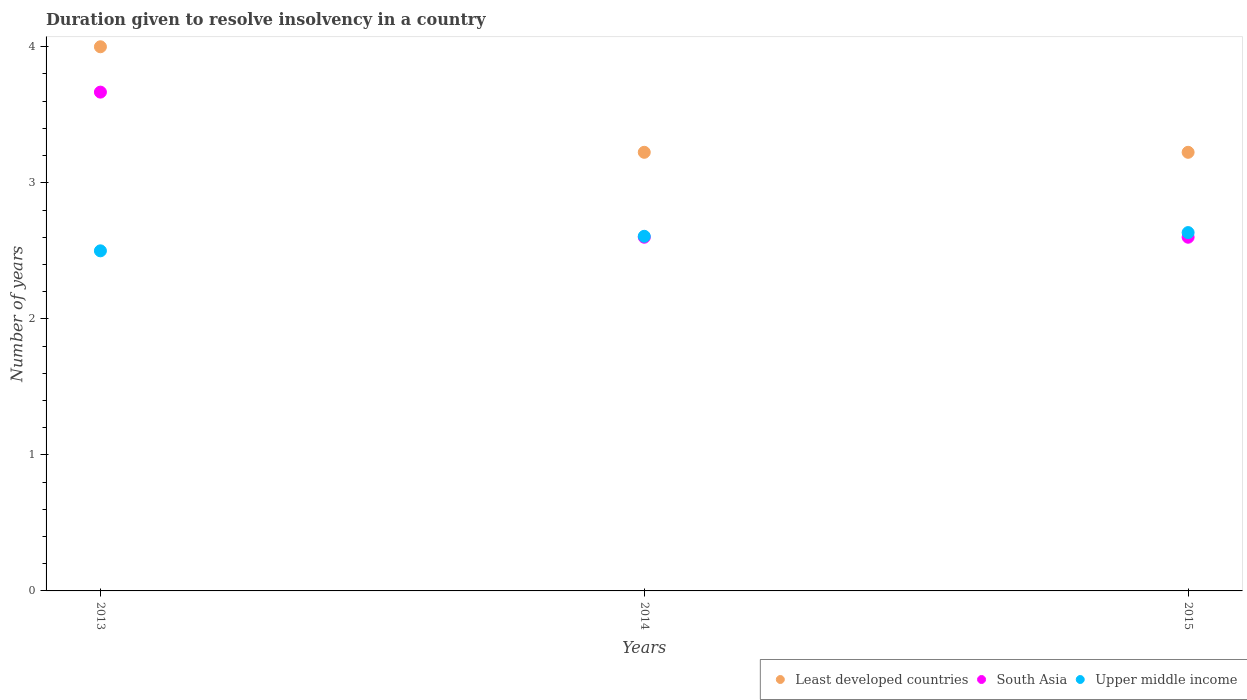Is the number of dotlines equal to the number of legend labels?
Give a very brief answer. Yes. What is the duration given to resolve insolvency in in Least developed countries in 2014?
Ensure brevity in your answer.  3.22. Across all years, what is the maximum duration given to resolve insolvency in in Upper middle income?
Keep it short and to the point. 2.63. Across all years, what is the minimum duration given to resolve insolvency in in Least developed countries?
Ensure brevity in your answer.  3.22. In which year was the duration given to resolve insolvency in in Upper middle income maximum?
Provide a short and direct response. 2015. What is the total duration given to resolve insolvency in in Least developed countries in the graph?
Ensure brevity in your answer.  10.45. What is the difference between the duration given to resolve insolvency in in Upper middle income in 2014 and that in 2015?
Offer a very short reply. -0.03. What is the difference between the duration given to resolve insolvency in in Least developed countries in 2015 and the duration given to resolve insolvency in in South Asia in 2014?
Offer a very short reply. 0.62. What is the average duration given to resolve insolvency in in South Asia per year?
Provide a short and direct response. 2.96. In the year 2014, what is the difference between the duration given to resolve insolvency in in Upper middle income and duration given to resolve insolvency in in Least developed countries?
Give a very brief answer. -0.62. What is the ratio of the duration given to resolve insolvency in in Upper middle income in 2014 to that in 2015?
Keep it short and to the point. 0.99. Is the difference between the duration given to resolve insolvency in in Upper middle income in 2013 and 2014 greater than the difference between the duration given to resolve insolvency in in Least developed countries in 2013 and 2014?
Your answer should be very brief. No. What is the difference between the highest and the second highest duration given to resolve insolvency in in Least developed countries?
Provide a short and direct response. 0.78. What is the difference between the highest and the lowest duration given to resolve insolvency in in Upper middle income?
Give a very brief answer. 0.13. Is it the case that in every year, the sum of the duration given to resolve insolvency in in South Asia and duration given to resolve insolvency in in Least developed countries  is greater than the duration given to resolve insolvency in in Upper middle income?
Ensure brevity in your answer.  Yes. Is the duration given to resolve insolvency in in South Asia strictly less than the duration given to resolve insolvency in in Upper middle income over the years?
Your response must be concise. No. Are the values on the major ticks of Y-axis written in scientific E-notation?
Provide a succinct answer. No. Where does the legend appear in the graph?
Your answer should be very brief. Bottom right. What is the title of the graph?
Offer a very short reply. Duration given to resolve insolvency in a country. What is the label or title of the Y-axis?
Your answer should be very brief. Number of years. What is the Number of years of South Asia in 2013?
Provide a short and direct response. 3.67. What is the Number of years of Least developed countries in 2014?
Provide a succinct answer. 3.22. What is the Number of years of South Asia in 2014?
Give a very brief answer. 2.6. What is the Number of years in Upper middle income in 2014?
Offer a terse response. 2.61. What is the Number of years in Least developed countries in 2015?
Your response must be concise. 3.22. What is the Number of years of Upper middle income in 2015?
Keep it short and to the point. 2.63. Across all years, what is the maximum Number of years of Least developed countries?
Give a very brief answer. 4. Across all years, what is the maximum Number of years of South Asia?
Keep it short and to the point. 3.67. Across all years, what is the maximum Number of years of Upper middle income?
Provide a short and direct response. 2.63. Across all years, what is the minimum Number of years of Least developed countries?
Keep it short and to the point. 3.22. Across all years, what is the minimum Number of years in Upper middle income?
Your answer should be compact. 2.5. What is the total Number of years of Least developed countries in the graph?
Provide a succinct answer. 10.45. What is the total Number of years of South Asia in the graph?
Make the answer very short. 8.87. What is the total Number of years in Upper middle income in the graph?
Your answer should be very brief. 7.74. What is the difference between the Number of years in Least developed countries in 2013 and that in 2014?
Keep it short and to the point. 0.78. What is the difference between the Number of years in South Asia in 2013 and that in 2014?
Ensure brevity in your answer.  1.07. What is the difference between the Number of years in Upper middle income in 2013 and that in 2014?
Offer a very short reply. -0.11. What is the difference between the Number of years in Least developed countries in 2013 and that in 2015?
Your response must be concise. 0.78. What is the difference between the Number of years of South Asia in 2013 and that in 2015?
Make the answer very short. 1.07. What is the difference between the Number of years of Upper middle income in 2013 and that in 2015?
Give a very brief answer. -0.13. What is the difference between the Number of years of Least developed countries in 2014 and that in 2015?
Offer a terse response. 0. What is the difference between the Number of years in South Asia in 2014 and that in 2015?
Make the answer very short. 0. What is the difference between the Number of years in Upper middle income in 2014 and that in 2015?
Offer a very short reply. -0.03. What is the difference between the Number of years in Least developed countries in 2013 and the Number of years in Upper middle income in 2014?
Provide a short and direct response. 1.39. What is the difference between the Number of years of South Asia in 2013 and the Number of years of Upper middle income in 2014?
Make the answer very short. 1.06. What is the difference between the Number of years in Least developed countries in 2013 and the Number of years in Upper middle income in 2015?
Ensure brevity in your answer.  1.37. What is the difference between the Number of years of South Asia in 2013 and the Number of years of Upper middle income in 2015?
Offer a very short reply. 1.03. What is the difference between the Number of years in Least developed countries in 2014 and the Number of years in South Asia in 2015?
Make the answer very short. 0.62. What is the difference between the Number of years of Least developed countries in 2014 and the Number of years of Upper middle income in 2015?
Your answer should be compact. 0.59. What is the difference between the Number of years of South Asia in 2014 and the Number of years of Upper middle income in 2015?
Make the answer very short. -0.03. What is the average Number of years in Least developed countries per year?
Ensure brevity in your answer.  3.48. What is the average Number of years in South Asia per year?
Your answer should be compact. 2.96. What is the average Number of years in Upper middle income per year?
Ensure brevity in your answer.  2.58. In the year 2013, what is the difference between the Number of years of Least developed countries and Number of years of South Asia?
Ensure brevity in your answer.  0.33. In the year 2013, what is the difference between the Number of years of Least developed countries and Number of years of Upper middle income?
Your answer should be compact. 1.5. In the year 2013, what is the difference between the Number of years in South Asia and Number of years in Upper middle income?
Make the answer very short. 1.17. In the year 2014, what is the difference between the Number of years in Least developed countries and Number of years in South Asia?
Ensure brevity in your answer.  0.62. In the year 2014, what is the difference between the Number of years in Least developed countries and Number of years in Upper middle income?
Offer a terse response. 0.62. In the year 2014, what is the difference between the Number of years of South Asia and Number of years of Upper middle income?
Give a very brief answer. -0.01. In the year 2015, what is the difference between the Number of years in Least developed countries and Number of years in South Asia?
Give a very brief answer. 0.62. In the year 2015, what is the difference between the Number of years in Least developed countries and Number of years in Upper middle income?
Offer a terse response. 0.59. In the year 2015, what is the difference between the Number of years of South Asia and Number of years of Upper middle income?
Ensure brevity in your answer.  -0.03. What is the ratio of the Number of years in Least developed countries in 2013 to that in 2014?
Keep it short and to the point. 1.24. What is the ratio of the Number of years of South Asia in 2013 to that in 2014?
Make the answer very short. 1.41. What is the ratio of the Number of years in Upper middle income in 2013 to that in 2014?
Provide a short and direct response. 0.96. What is the ratio of the Number of years in Least developed countries in 2013 to that in 2015?
Ensure brevity in your answer.  1.24. What is the ratio of the Number of years of South Asia in 2013 to that in 2015?
Give a very brief answer. 1.41. What is the ratio of the Number of years of Upper middle income in 2013 to that in 2015?
Provide a short and direct response. 0.95. What is the ratio of the Number of years of Least developed countries in 2014 to that in 2015?
Your response must be concise. 1. What is the ratio of the Number of years of Upper middle income in 2014 to that in 2015?
Offer a terse response. 0.99. What is the difference between the highest and the second highest Number of years of Least developed countries?
Your response must be concise. 0.78. What is the difference between the highest and the second highest Number of years in South Asia?
Make the answer very short. 1.07. What is the difference between the highest and the second highest Number of years in Upper middle income?
Your answer should be compact. 0.03. What is the difference between the highest and the lowest Number of years of Least developed countries?
Make the answer very short. 0.78. What is the difference between the highest and the lowest Number of years of South Asia?
Your answer should be very brief. 1.07. What is the difference between the highest and the lowest Number of years of Upper middle income?
Your answer should be very brief. 0.13. 